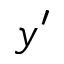<formula> <loc_0><loc_0><loc_500><loc_500>y ^ { \prime }</formula> 